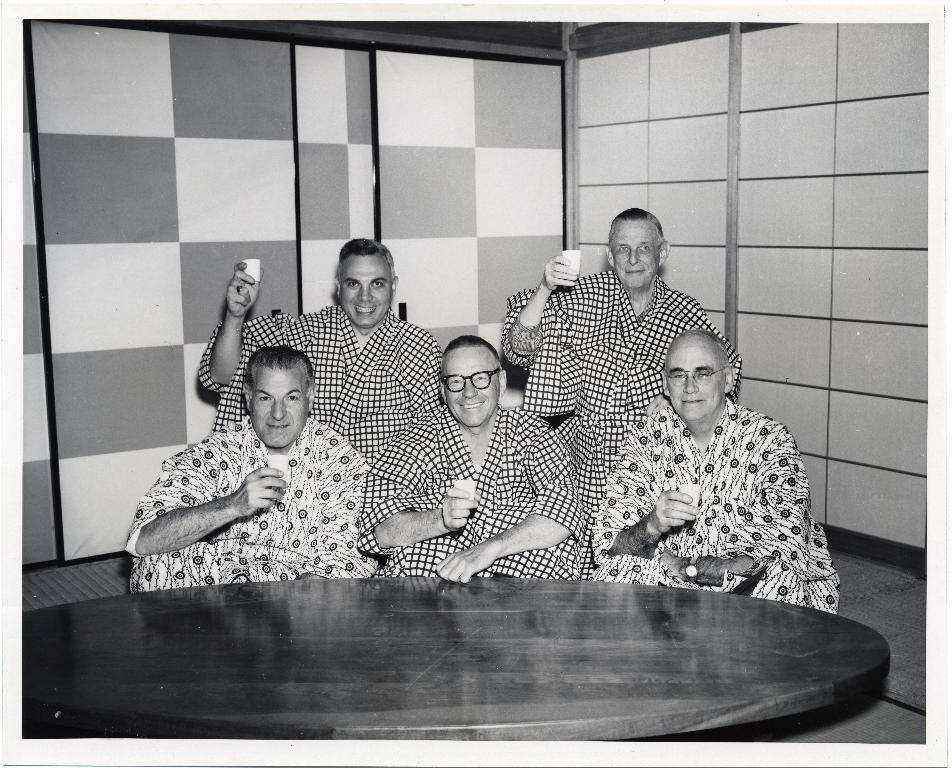How many people are present in the image? There are five people sitting in the image. What are the people holding in their hands? The people are holding glasses. Can you describe the person in the center? The person in the center is wearing glasses (specs). What is in front of the people? There is a table in front of the people. What is the background of the image? The background of the image features a check wall. What type of bean is being served in a vessel on the table? There is no bean or vessel present on the table in the image. What type of trousers is the person in the center wearing? The provided facts do not mention the type of trousers the person in the center is wearing. 